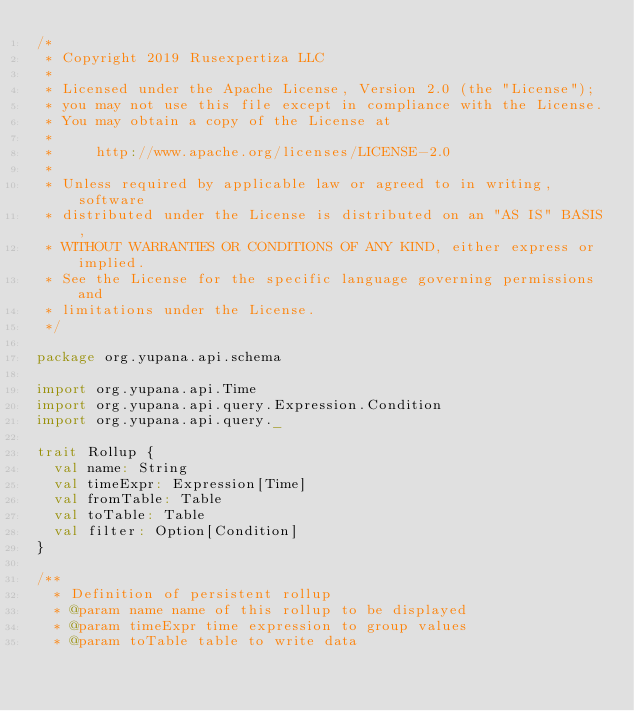<code> <loc_0><loc_0><loc_500><loc_500><_Scala_>/*
 * Copyright 2019 Rusexpertiza LLC
 *
 * Licensed under the Apache License, Version 2.0 (the "License");
 * you may not use this file except in compliance with the License.
 * You may obtain a copy of the License at
 *
 *     http://www.apache.org/licenses/LICENSE-2.0
 *
 * Unless required by applicable law or agreed to in writing, software
 * distributed under the License is distributed on an "AS IS" BASIS,
 * WITHOUT WARRANTIES OR CONDITIONS OF ANY KIND, either express or implied.
 * See the License for the specific language governing permissions and
 * limitations under the License.
 */

package org.yupana.api.schema

import org.yupana.api.Time
import org.yupana.api.query.Expression.Condition
import org.yupana.api.query._

trait Rollup {
  val name: String
  val timeExpr: Expression[Time]
  val fromTable: Table
  val toTable: Table
  val filter: Option[Condition]
}

/**
  * Definition of persistent rollup
  * @param name name of this rollup to be displayed
  * @param timeExpr time expression to group values
  * @param toTable table to write data</code> 